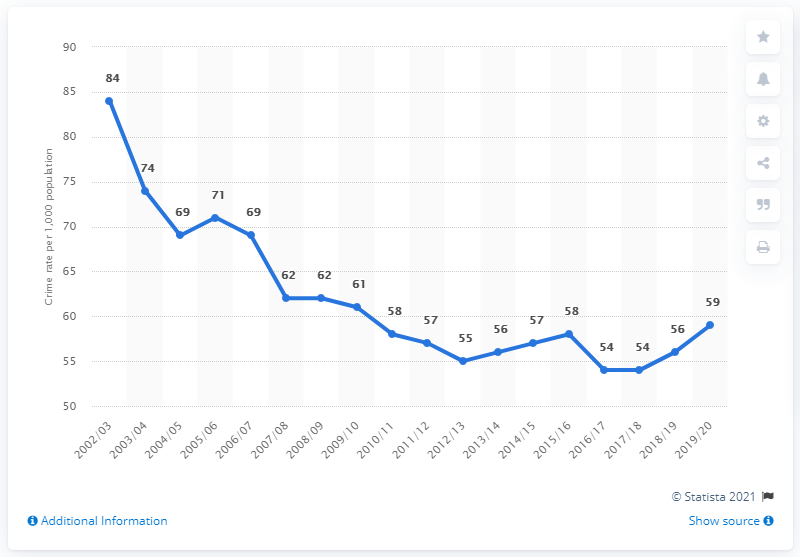Can you point out any periods with significant changes in crime rates? Certainly, if we examine the chart, a significant drop in crime rates is observed between 2003/04 and 2004/05, where the rate falls from 84 to 74 incidents per 1,000 population. Another notable change includes the decrease from 2007/08 to 2009/10, where the rate drops from 71 to 61 incidents. Conversely, the period between 2018/19 and 2019/20 shows a notable increase from 56 to 59 incidents per 1,000 population. 